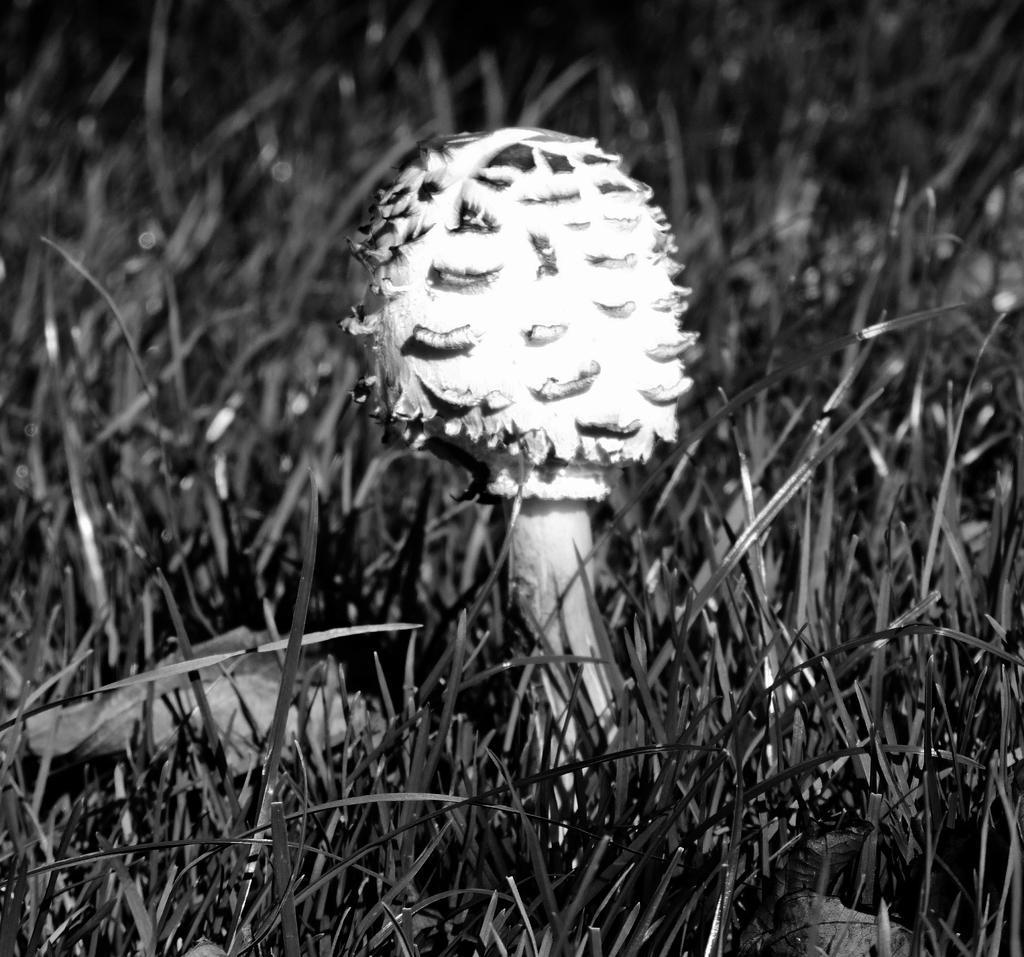Describe this image in one or two sentences. This image consists of a plant in white color. At the bottom, there is grass. 